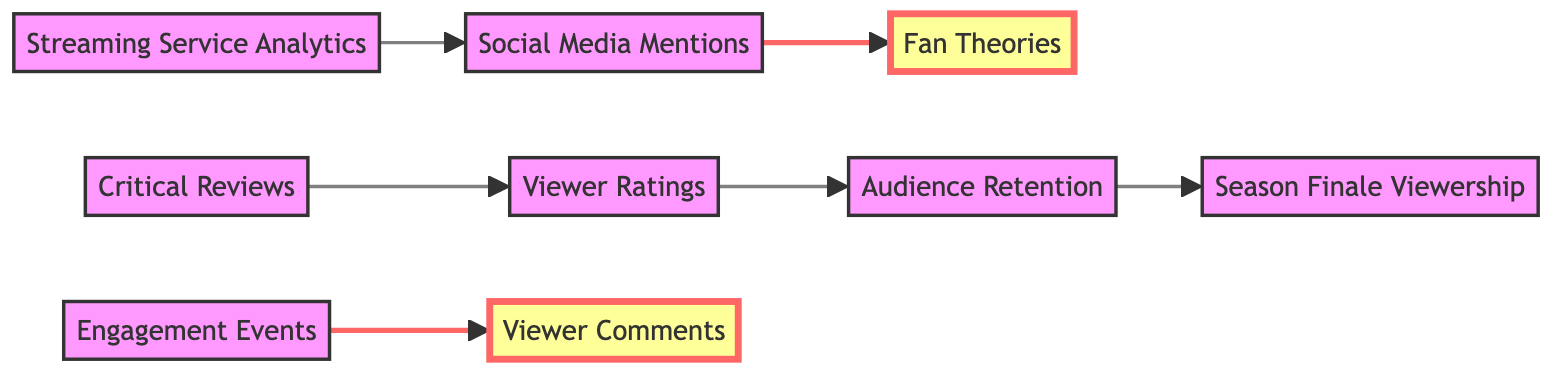What is the relationship between Viewer Ratings and Audience Retention? The diagram shows a directed edge going from Viewer Ratings to Audience Retention, indicating that viewer ratings can influence how well audiences retain their attention throughout episodes or seasons.
Answer: Audience Retention How many nodes are present in the diagram? The diagram contains eight unique elements or nodes, each representing different viewer engagement metrics.
Answer: Eight Which node has the most connections? Through tallying the directed edges, Social Media Mentions and Audience Retention both have only one outgoing edge, while Viewer Ratings has two, indicating it has the most connections.
Answer: Viewer Ratings What does the directed edge from Social Media Mentions to Fan Theories suggest? This directed edge implies that social media mentions may inspire or generate fan theories, indicating a relationship where discussions can lead to creative interpretations among fans.
Answer: It suggests a relationship where mentions can inspire theories What nodes are highlighted in the diagram? The highlighted nodes in the diagram are Fan Theories and Viewer Comments, which are emphasized to indicate their significance in showcasing fan engagement.
Answer: Fan Theories, Viewer Comments What do Engagement Events lead to in the diagram? According to the diagram, Engagement Events have a directed edge leading to Viewer Comments, suggesting that such events increase viewer feedback through comments.
Answer: Viewer Comments How many edges are present in the diagram? By counting each directed relationship in the diagram, there are a total of six edges that illustrate connections between the various metrics.
Answer: Six What can be inferred from the flow from Critical Reviews to Viewer Ratings? The directed edge indicates that critical reviews can affect or contribute to viewer ratings, possibly informing viewers' perceptions before rating the show.
Answer: Critical reviews can affect viewer ratings 